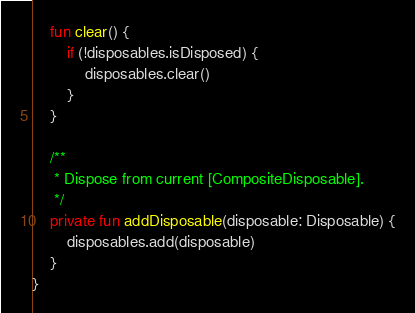<code> <loc_0><loc_0><loc_500><loc_500><_Kotlin_>
    fun clear() {
        if (!disposables.isDisposed) {
            disposables.clear()
        }
    }

    /**
     * Dispose from current [CompositeDisposable].
     */
    private fun addDisposable(disposable: Disposable) {
        disposables.add(disposable)
    }
}</code> 